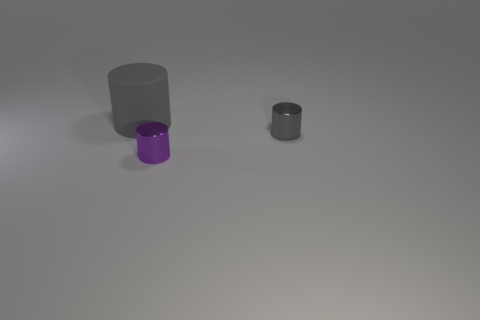Is there any other thing that is the same size as the gray matte cylinder?
Your response must be concise. No. Is there any other thing that has the same material as the large gray cylinder?
Provide a succinct answer. No. The purple shiny thing that is the same shape as the gray matte thing is what size?
Give a very brief answer. Small. There is a thing that is both left of the small gray metallic thing and in front of the large gray thing; what is its material?
Your response must be concise. Metal. There is a small cylinder behind the purple metallic cylinder; is it the same color as the big cylinder?
Your response must be concise. Yes. Do the large object and the small thing that is to the right of the small purple metallic cylinder have the same color?
Provide a succinct answer. Yes. Are there any metal cylinders behind the small purple metal cylinder?
Your answer should be compact. Yes. Does the tiny purple cylinder have the same material as the small gray cylinder?
Your answer should be very brief. Yes. What number of things are either cylinders that are left of the gray metallic thing or tiny gray metallic things?
Provide a short and direct response. 3. Are there an equal number of gray matte cylinders that are right of the large matte cylinder and large blue rubber cubes?
Make the answer very short. Yes. 